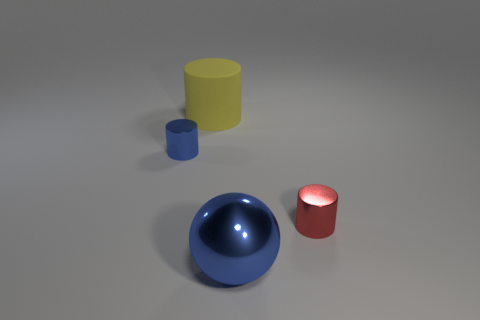What is the color of the metallic cylinder that is behind the metal cylinder in front of the small thing that is left of the small red shiny cylinder?
Offer a very short reply. Blue. Does the small cylinder that is left of the big shiny ball have the same color as the metal thing that is in front of the small red thing?
Offer a terse response. Yes. Is there any other thing of the same color as the big metallic sphere?
Offer a very short reply. Yes. Are there fewer large blue spheres on the left side of the yellow cylinder than tiny objects?
Your answer should be compact. Yes. How many big gray balls are there?
Offer a terse response. 0. Do the matte thing and the blue thing that is on the right side of the big matte object have the same shape?
Provide a succinct answer. No. Are there fewer large metallic things that are behind the red metallic object than large blue shiny spheres to the right of the big rubber cylinder?
Provide a succinct answer. Yes. Is there any other thing that has the same shape as the yellow matte thing?
Ensure brevity in your answer.  Yes. Do the big metal object and the small red object have the same shape?
Offer a very short reply. No. Is there any other thing that has the same material as the big cylinder?
Your answer should be compact. No. 